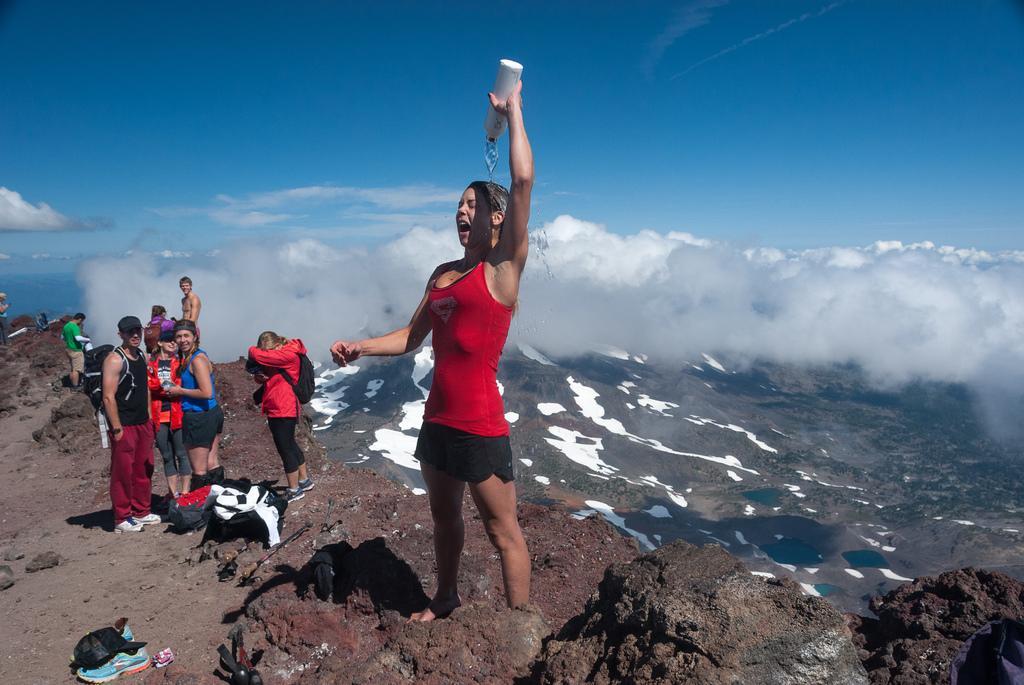Can you describe this image briefly? In this image in the foreground there is one woman who is standing, and she is holding a bottle and pouring water on herself. On the left side there are some people who are standing and some of them are wearing bags, at the bottom there are some mountains and we could see some bags, cap, hat and some shoes. In the background there are some mountains, on the top of the image there is sky. 